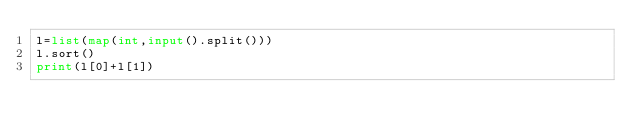<code> <loc_0><loc_0><loc_500><loc_500><_Python_>l=list(map(int,input().split()))
l.sort()
print(l[0]+l[1])</code> 